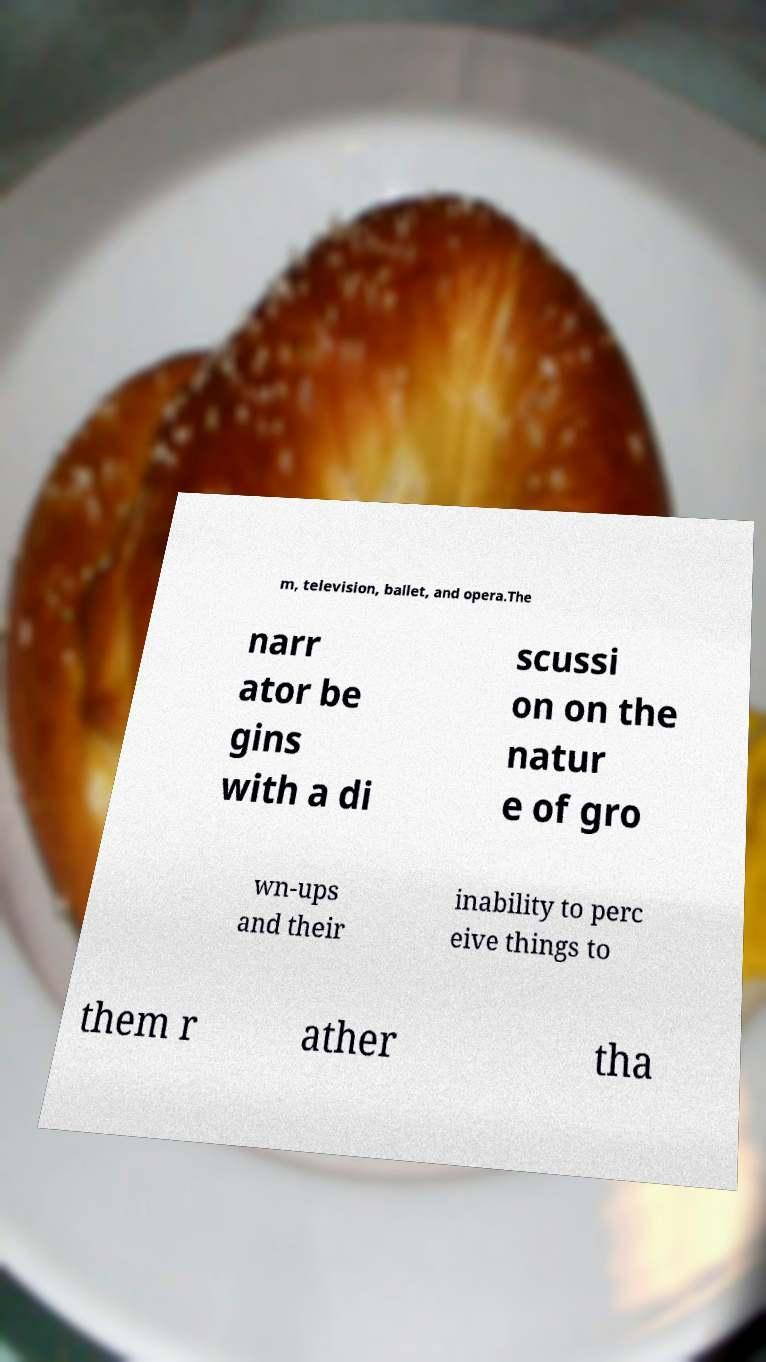For documentation purposes, I need the text within this image transcribed. Could you provide that? m, television, ballet, and opera.The narr ator be gins with a di scussi on on the natur e of gro wn-ups and their inability to perc eive things to them r ather tha 